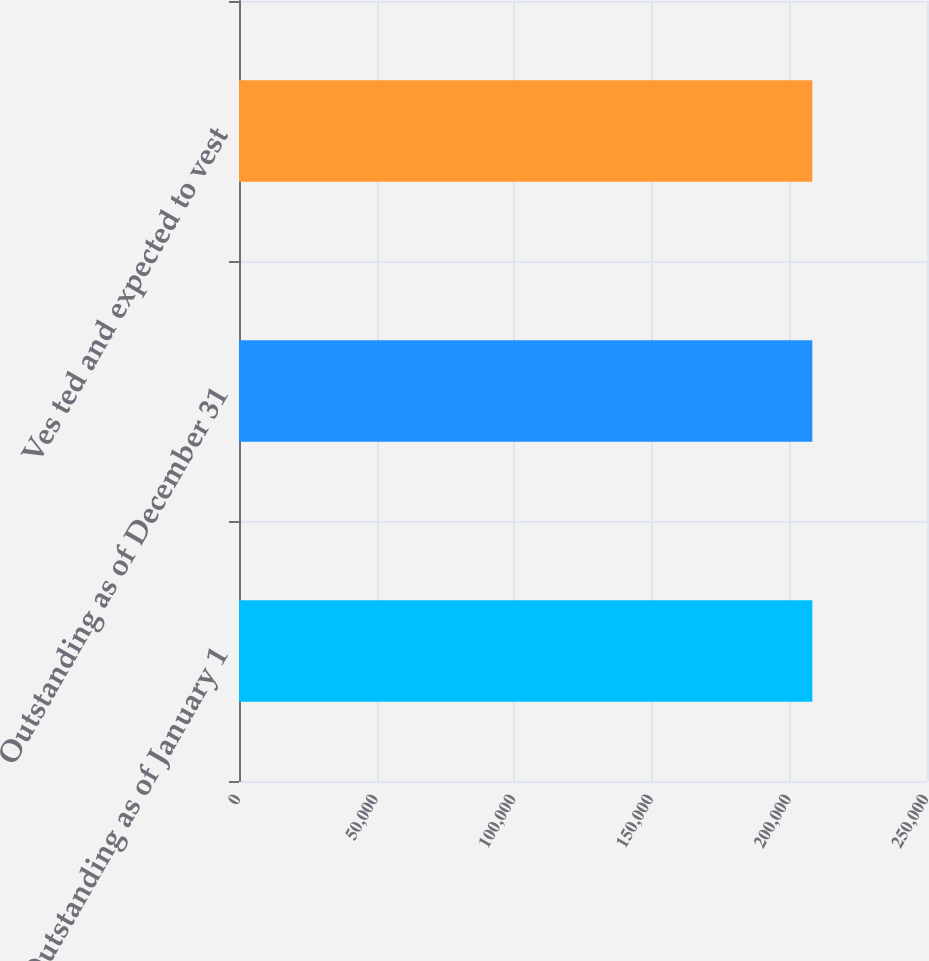Convert chart. <chart><loc_0><loc_0><loc_500><loc_500><bar_chart><fcel>Outstanding as of January 1<fcel>Outstanding as of December 31<fcel>Ves ted and expected to vest<nl><fcel>208333<fcel>208333<fcel>208333<nl></chart> 